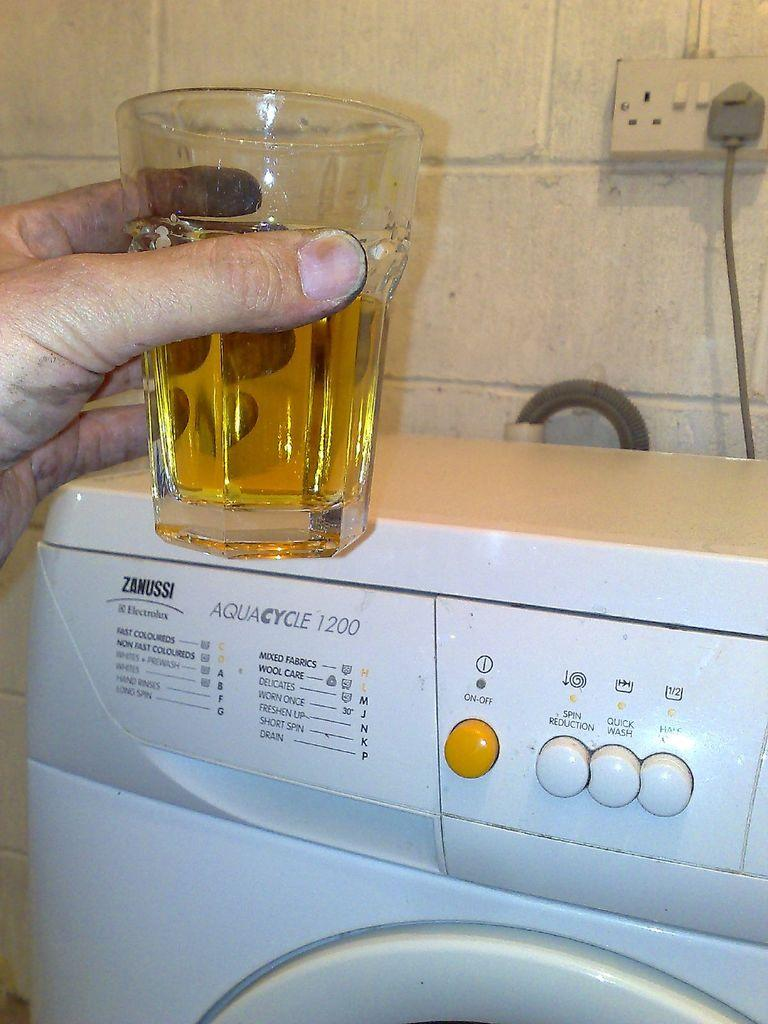<image>
Share a concise interpretation of the image provided. Someone is holding a drink near a washing machine with a spin reduction button. 